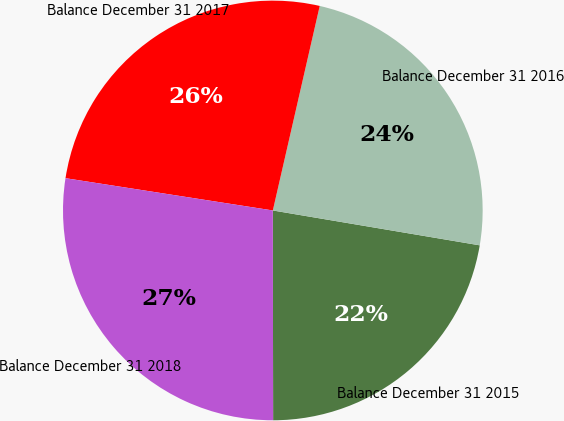<chart> <loc_0><loc_0><loc_500><loc_500><pie_chart><fcel>Balance December 31 2015<fcel>Balance December 31 2016<fcel>Balance December 31 2017<fcel>Balance December 31 2018<nl><fcel>22.32%<fcel>24.07%<fcel>26.13%<fcel>27.48%<nl></chart> 